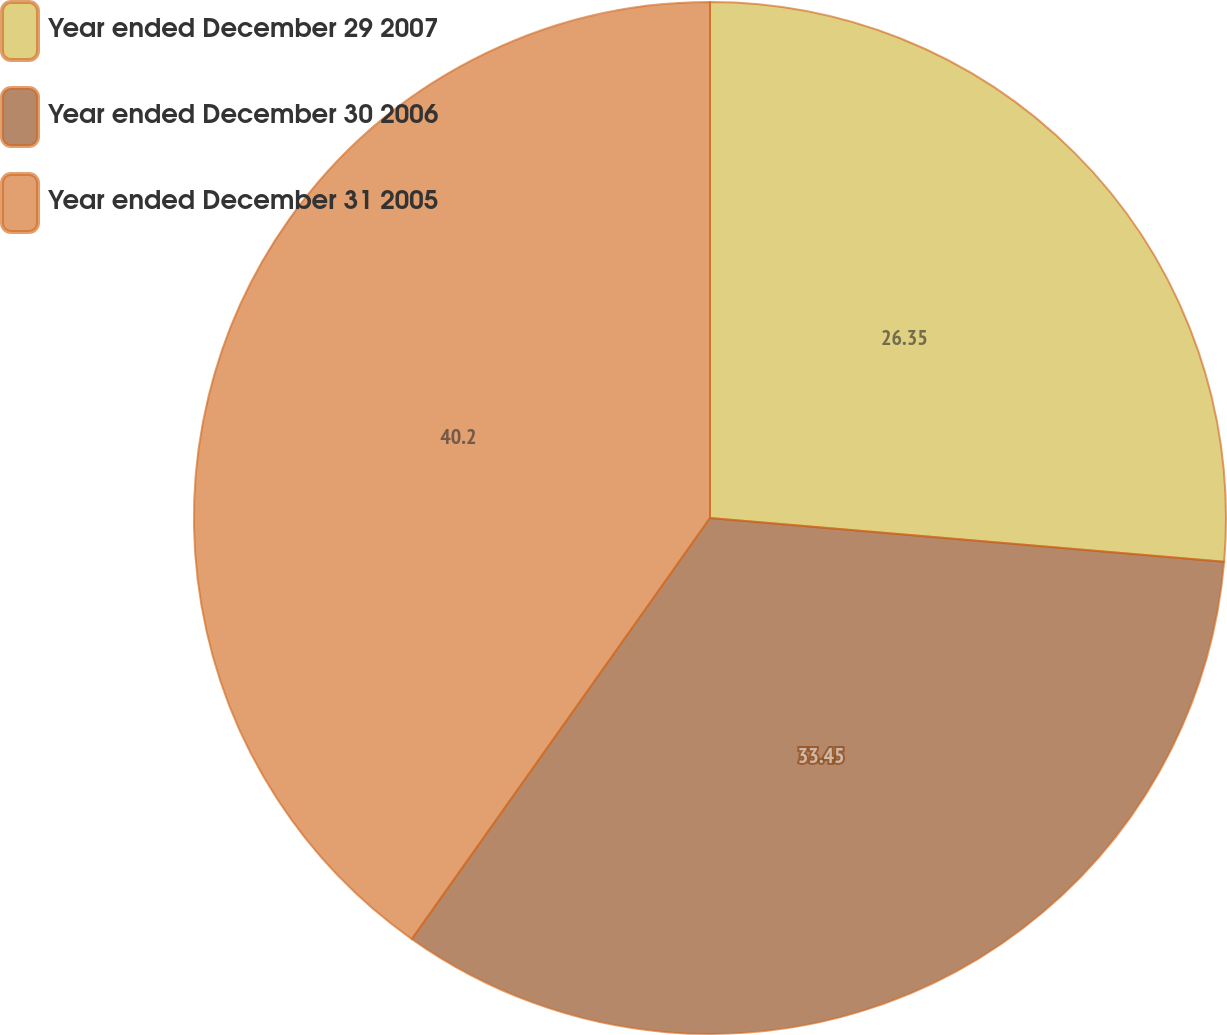Convert chart. <chart><loc_0><loc_0><loc_500><loc_500><pie_chart><fcel>Year ended December 29 2007<fcel>Year ended December 30 2006<fcel>Year ended December 31 2005<nl><fcel>26.35%<fcel>33.45%<fcel>40.19%<nl></chart> 